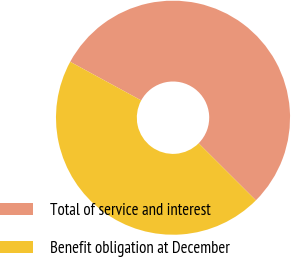Convert chart to OTSL. <chart><loc_0><loc_0><loc_500><loc_500><pie_chart><fcel>Total of service and interest<fcel>Benefit obligation at December<nl><fcel>54.55%<fcel>45.45%<nl></chart> 